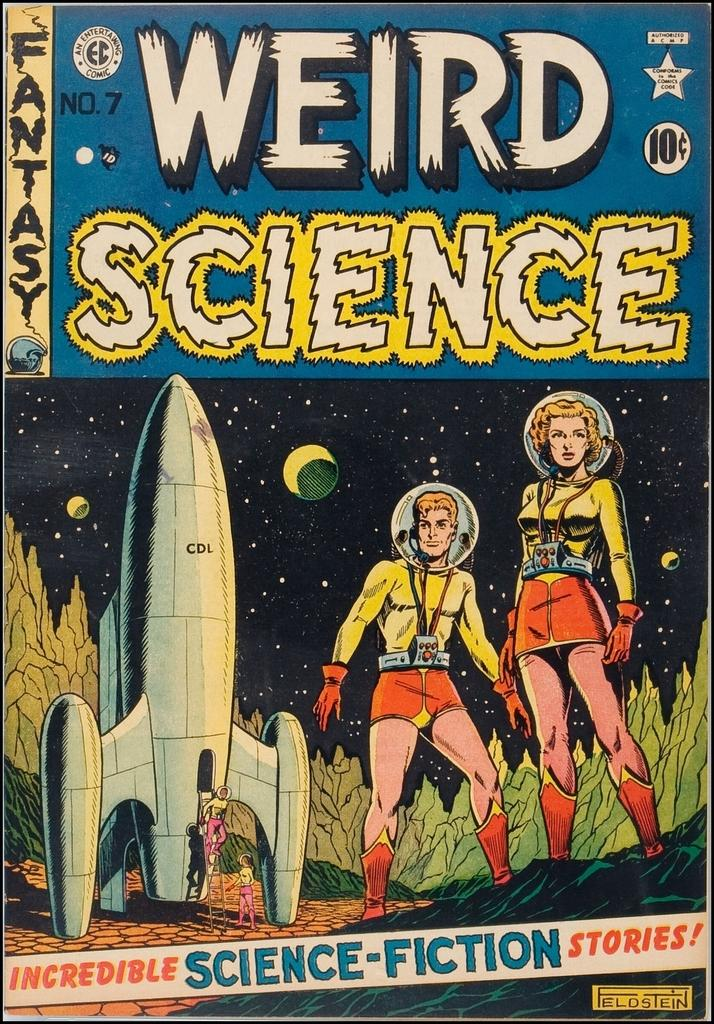Provide a one-sentence caption for the provided image. Volume number seven of the Weird Science comic book series. 